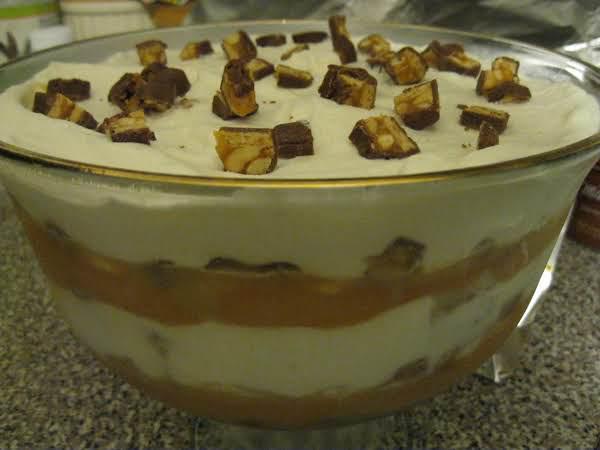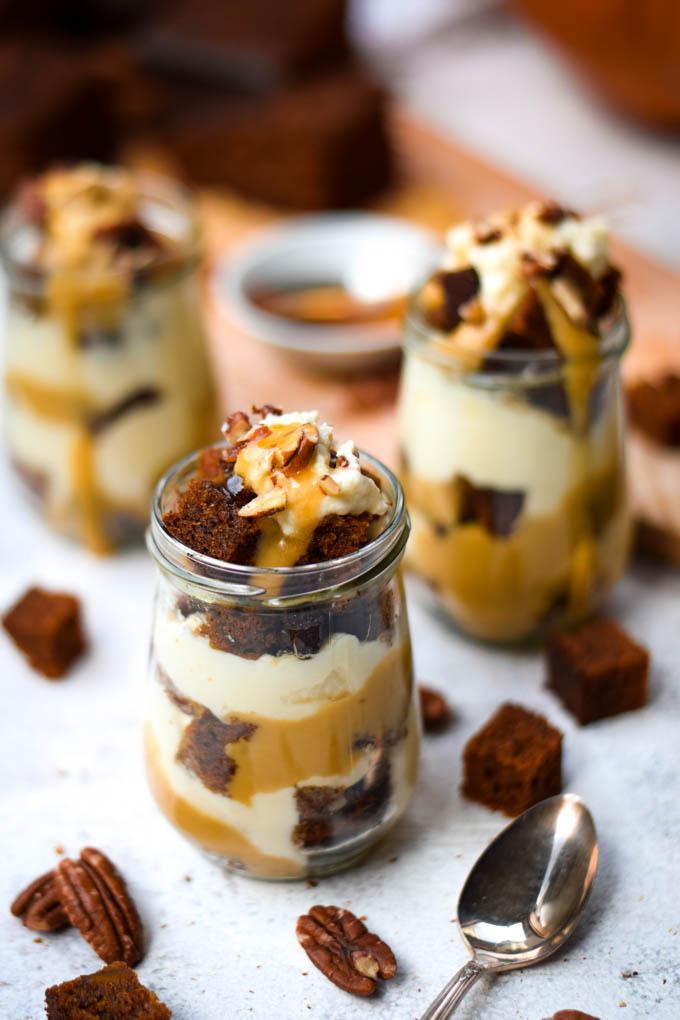The first image is the image on the left, the second image is the image on the right. Analyze the images presented: Is the assertion "One large fancy dessert and three servings of a different dessert are shown." valid? Answer yes or no. Yes. 